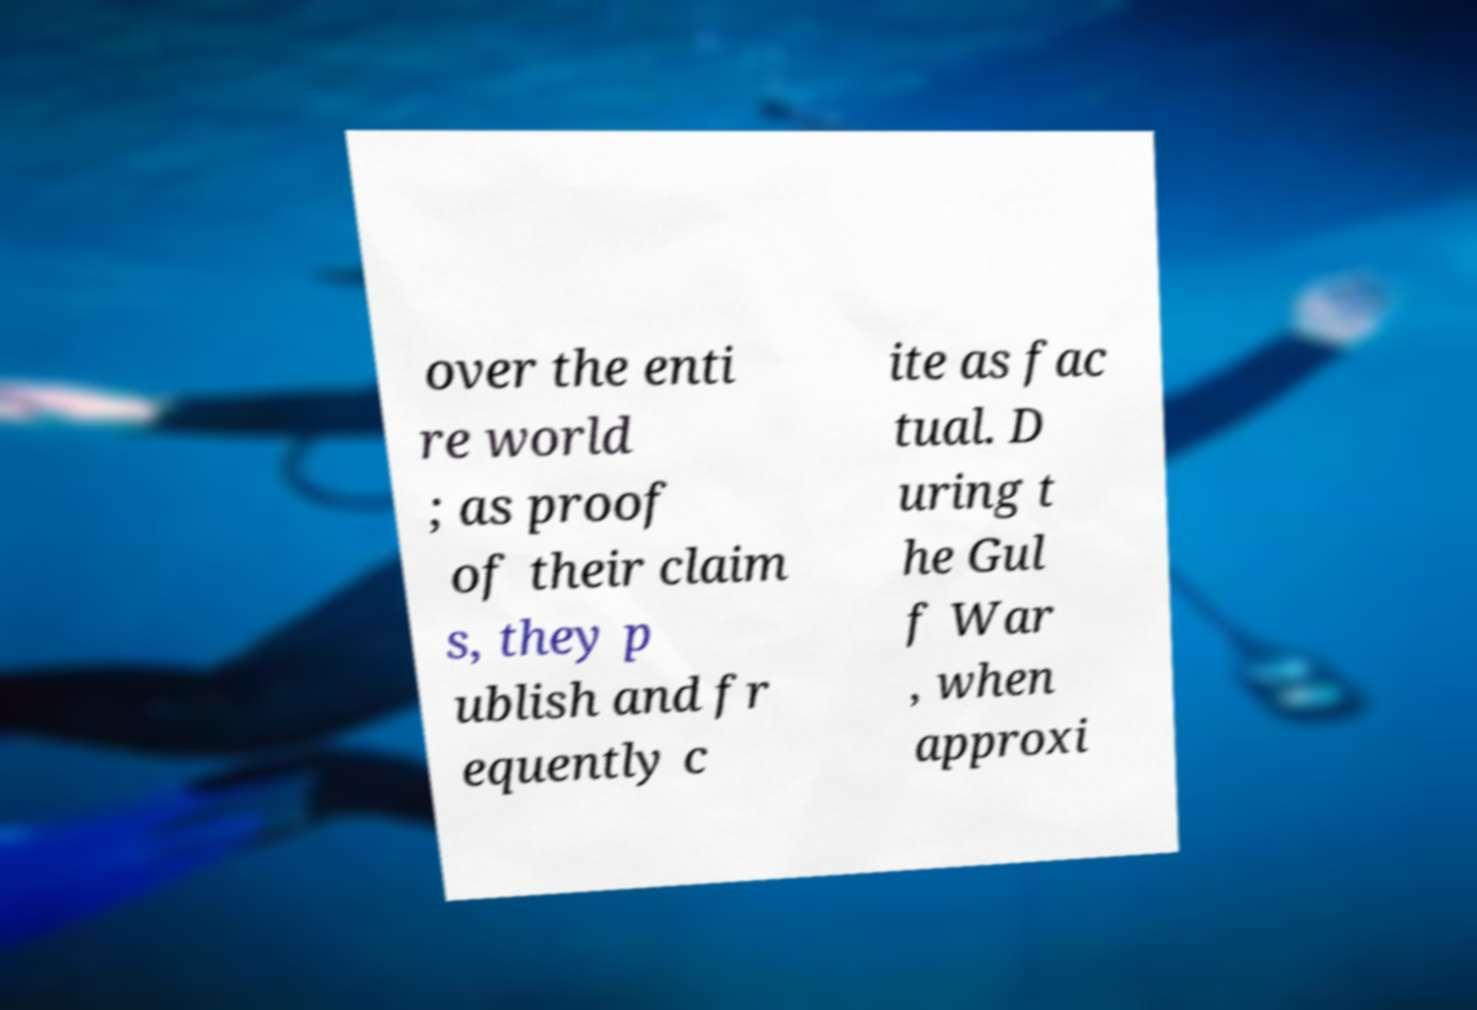Please read and relay the text visible in this image. What does it say? over the enti re world ; as proof of their claim s, they p ublish and fr equently c ite as fac tual. D uring t he Gul f War , when approxi 